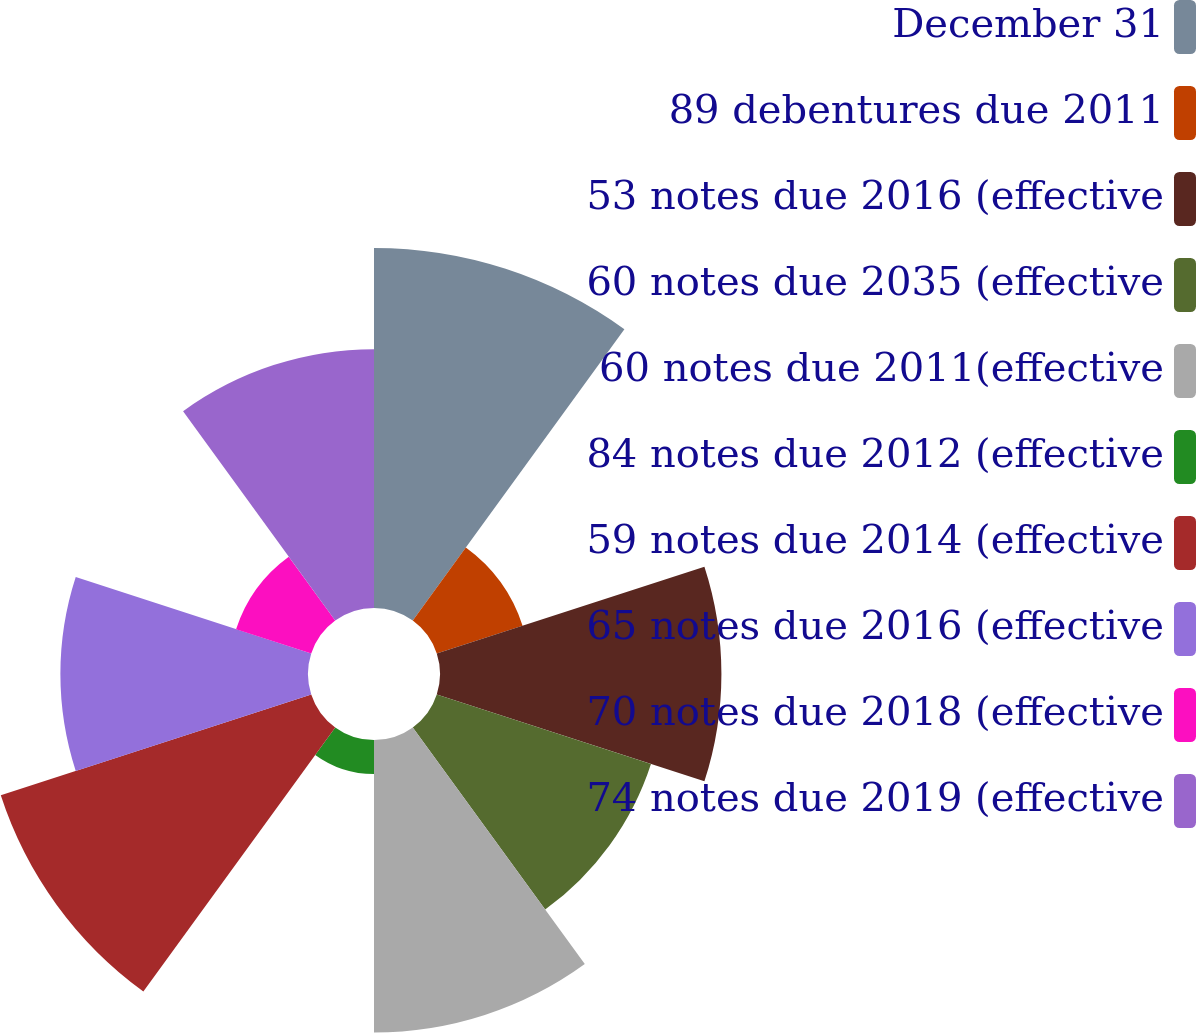<chart> <loc_0><loc_0><loc_500><loc_500><pie_chart><fcel>December 31<fcel>89 debentures due 2011<fcel>53 notes due 2016 (effective<fcel>60 notes due 2035 (effective<fcel>60 notes due 2011(effective<fcel>84 notes due 2012 (effective<fcel>59 notes due 2014 (effective<fcel>65 notes due 2016 (effective<fcel>70 notes due 2018 (effective<fcel>74 notes due 2019 (effective<nl><fcel>16.4%<fcel>4.11%<fcel>12.82%<fcel>10.26%<fcel>13.33%<fcel>1.55%<fcel>14.87%<fcel>11.28%<fcel>3.6%<fcel>11.79%<nl></chart> 